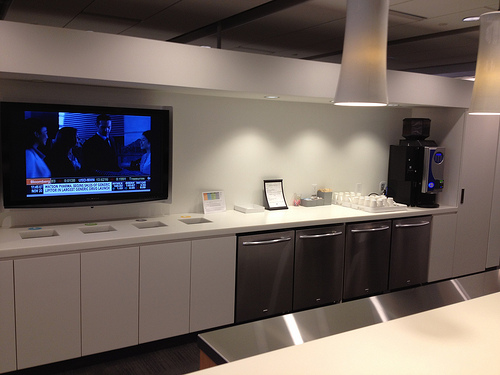Please provide the bounding box coordinate of the region this sentence describes: white door near coffee dispenser. The bounding box coordinates for the white door near the coffee dispenser are [0.91, 0.37, 0.99, 0.7]. 